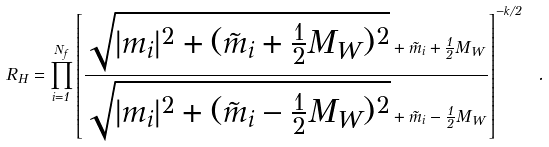Convert formula to latex. <formula><loc_0><loc_0><loc_500><loc_500>R _ { H } = \prod _ { i = 1 } ^ { N _ { f } } \left [ \frac { \sqrt { | m _ { i } | ^ { 2 } + ( { \tilde { m } } _ { i } + \frac { 1 } { 2 } M _ { W } ) ^ { 2 } } + { \tilde { m } } _ { i } + \frac { 1 } { 2 } M _ { W } } { \sqrt { | m _ { i } | ^ { 2 } + ( { \tilde { m } } _ { i } - \frac { 1 } { 2 } M _ { W } ) ^ { 2 } } + { \tilde { m } } _ { i } - \frac { 1 } { 2 } M _ { W } } \right ] ^ { - k / 2 } \ .</formula> 